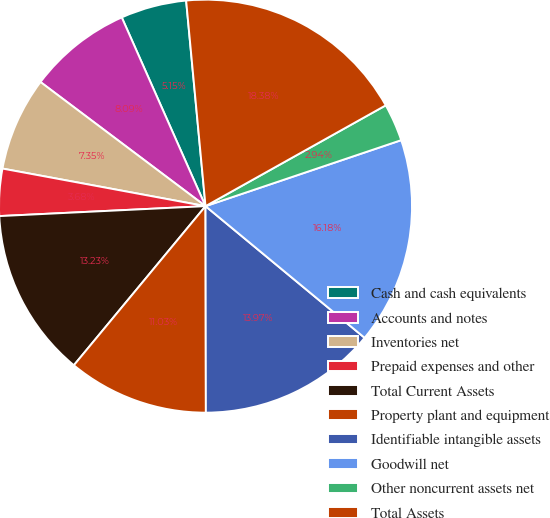Convert chart. <chart><loc_0><loc_0><loc_500><loc_500><pie_chart><fcel>Cash and cash equivalents<fcel>Accounts and notes<fcel>Inventories net<fcel>Prepaid expenses and other<fcel>Total Current Assets<fcel>Property plant and equipment<fcel>Identifiable intangible assets<fcel>Goodwill net<fcel>Other noncurrent assets net<fcel>Total Assets<nl><fcel>5.15%<fcel>8.09%<fcel>7.35%<fcel>3.68%<fcel>13.23%<fcel>11.03%<fcel>13.97%<fcel>16.18%<fcel>2.94%<fcel>18.38%<nl></chart> 